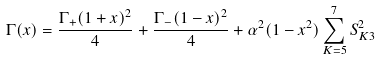Convert formula to latex. <formula><loc_0><loc_0><loc_500><loc_500>\Gamma ( x ) = \frac { \Gamma _ { + } ( 1 + x ) ^ { 2 } } { 4 } + \frac { \Gamma _ { - } ( 1 - x ) ^ { 2 } } { 4 } + \alpha ^ { 2 } ( 1 - x ^ { 2 } ) \sum _ { K = 5 } ^ { 7 } S _ { K 3 } ^ { 2 }</formula> 